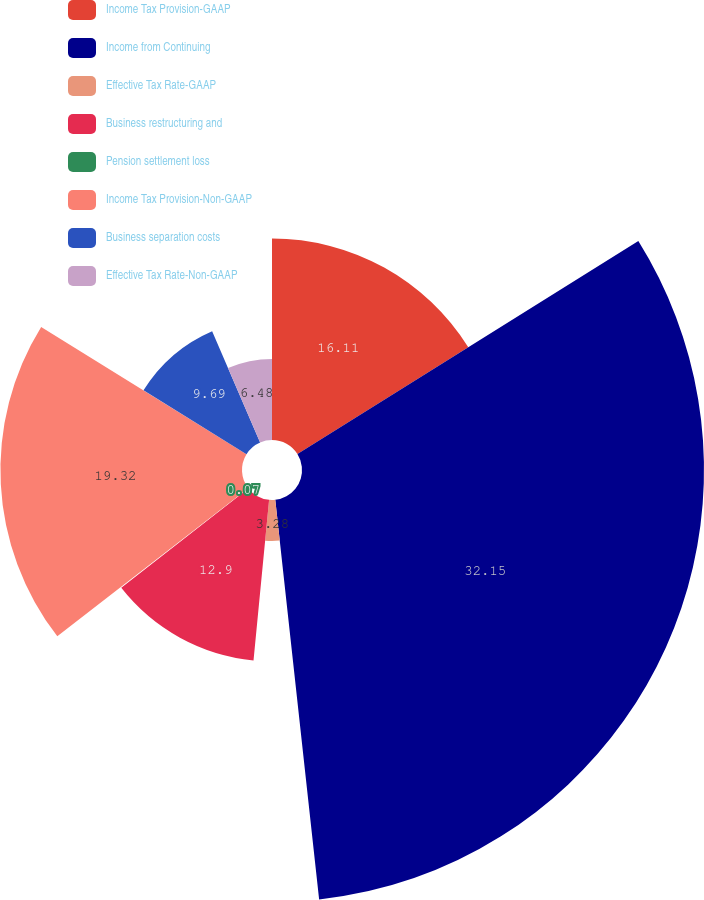<chart> <loc_0><loc_0><loc_500><loc_500><pie_chart><fcel>Income Tax Provision-GAAP<fcel>Income from Continuing<fcel>Effective Tax Rate-GAAP<fcel>Business restructuring and<fcel>Pension settlement loss<fcel>Income Tax Provision-Non-GAAP<fcel>Business separation costs<fcel>Effective Tax Rate-Non-GAAP<nl><fcel>16.11%<fcel>32.15%<fcel>3.28%<fcel>12.9%<fcel>0.07%<fcel>19.32%<fcel>9.69%<fcel>6.48%<nl></chart> 